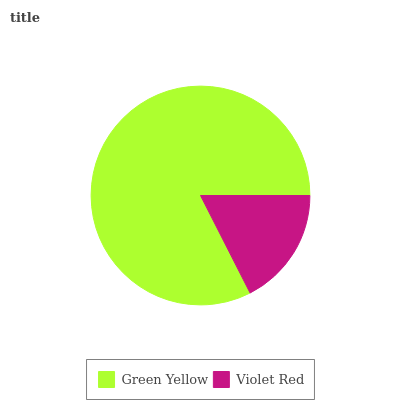Is Violet Red the minimum?
Answer yes or no. Yes. Is Green Yellow the maximum?
Answer yes or no. Yes. Is Violet Red the maximum?
Answer yes or no. No. Is Green Yellow greater than Violet Red?
Answer yes or no. Yes. Is Violet Red less than Green Yellow?
Answer yes or no. Yes. Is Violet Red greater than Green Yellow?
Answer yes or no. No. Is Green Yellow less than Violet Red?
Answer yes or no. No. Is Green Yellow the high median?
Answer yes or no. Yes. Is Violet Red the low median?
Answer yes or no. Yes. Is Violet Red the high median?
Answer yes or no. No. Is Green Yellow the low median?
Answer yes or no. No. 